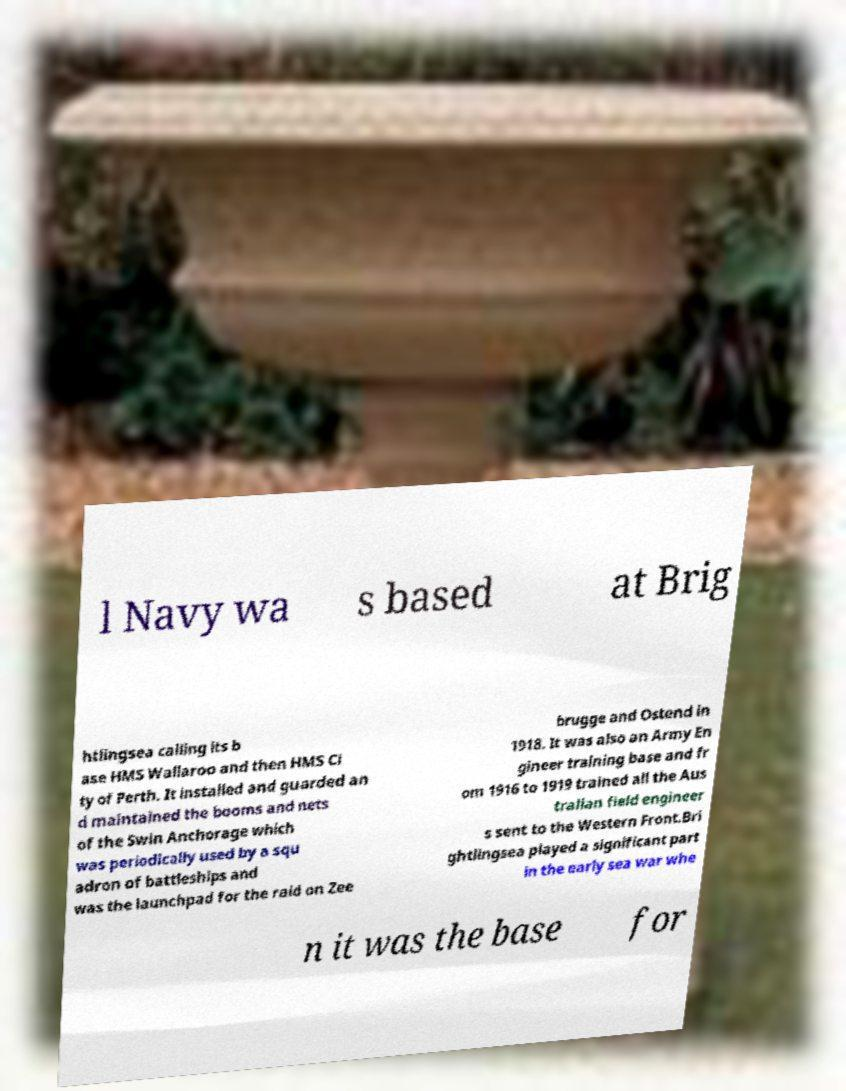Could you assist in decoding the text presented in this image and type it out clearly? l Navy wa s based at Brig htlingsea calling its b ase HMS Wallaroo and then HMS Ci ty of Perth. It installed and guarded an d maintained the booms and nets of the Swin Anchorage which was periodically used by a squ adron of battleships and was the launchpad for the raid on Zee brugge and Ostend in 1918. It was also an Army En gineer training base and fr om 1916 to 1919 trained all the Aus tralian field engineer s sent to the Western Front.Bri ghtlingsea played a significant part in the early sea war whe n it was the base for 